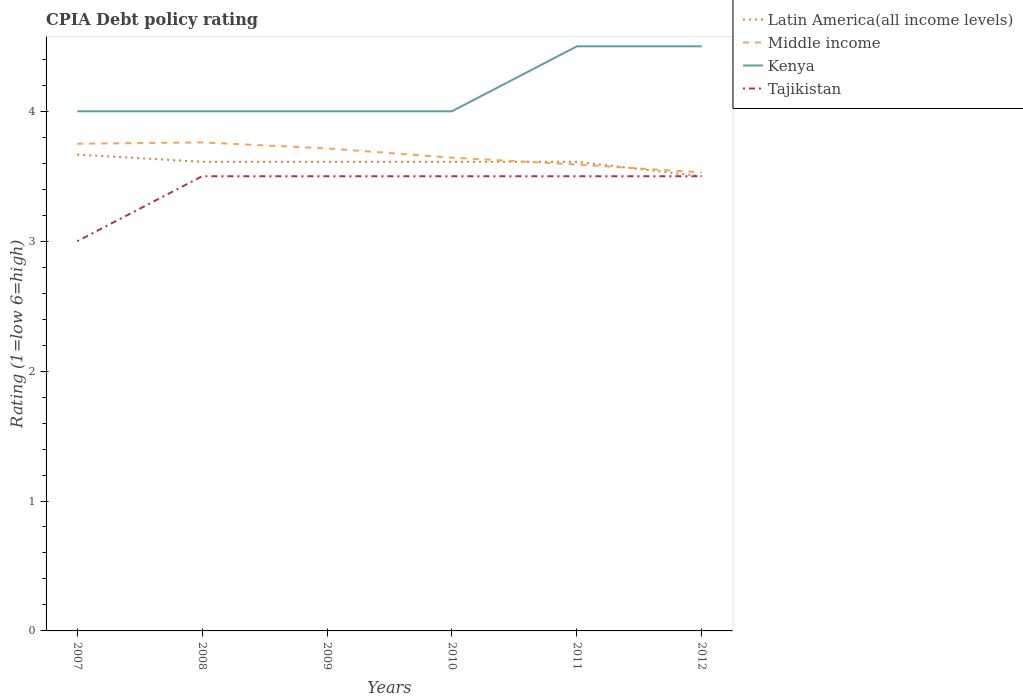Does the line corresponding to Latin America(all income levels) intersect with the line corresponding to Middle income?
Offer a very short reply. Yes. Is the number of lines equal to the number of legend labels?
Offer a terse response. Yes. Across all years, what is the maximum CPIA rating in Middle income?
Your answer should be very brief. 3.53. What is the total CPIA rating in Kenya in the graph?
Offer a very short reply. 0. What is the difference between the highest and the second highest CPIA rating in Latin America(all income levels)?
Your answer should be very brief. 0.17. What is the difference between the highest and the lowest CPIA rating in Kenya?
Your answer should be very brief. 2. Is the CPIA rating in Latin America(all income levels) strictly greater than the CPIA rating in Tajikistan over the years?
Your answer should be very brief. No. What is the difference between two consecutive major ticks on the Y-axis?
Ensure brevity in your answer.  1. Are the values on the major ticks of Y-axis written in scientific E-notation?
Give a very brief answer. No. What is the title of the graph?
Your response must be concise. CPIA Debt policy rating. What is the label or title of the Y-axis?
Ensure brevity in your answer.  Rating (1=low 6=high). What is the Rating (1=low 6=high) in Latin America(all income levels) in 2007?
Give a very brief answer. 3.67. What is the Rating (1=low 6=high) in Middle income in 2007?
Provide a short and direct response. 3.75. What is the Rating (1=low 6=high) of Tajikistan in 2007?
Ensure brevity in your answer.  3. What is the Rating (1=low 6=high) in Latin America(all income levels) in 2008?
Make the answer very short. 3.61. What is the Rating (1=low 6=high) of Middle income in 2008?
Offer a very short reply. 3.76. What is the Rating (1=low 6=high) of Kenya in 2008?
Offer a terse response. 4. What is the Rating (1=low 6=high) of Latin America(all income levels) in 2009?
Your response must be concise. 3.61. What is the Rating (1=low 6=high) of Middle income in 2009?
Give a very brief answer. 3.71. What is the Rating (1=low 6=high) of Tajikistan in 2009?
Keep it short and to the point. 3.5. What is the Rating (1=low 6=high) in Latin America(all income levels) in 2010?
Provide a short and direct response. 3.61. What is the Rating (1=low 6=high) of Middle income in 2010?
Offer a terse response. 3.64. What is the Rating (1=low 6=high) of Latin America(all income levels) in 2011?
Your answer should be very brief. 3.61. What is the Rating (1=low 6=high) in Middle income in 2011?
Your answer should be compact. 3.59. What is the Rating (1=low 6=high) of Tajikistan in 2011?
Offer a very short reply. 3.5. What is the Rating (1=low 6=high) in Latin America(all income levels) in 2012?
Offer a very short reply. 3.5. What is the Rating (1=low 6=high) in Middle income in 2012?
Offer a very short reply. 3.53. What is the Rating (1=low 6=high) in Kenya in 2012?
Offer a very short reply. 4.5. What is the Rating (1=low 6=high) of Tajikistan in 2012?
Provide a short and direct response. 3.5. Across all years, what is the maximum Rating (1=low 6=high) in Latin America(all income levels)?
Ensure brevity in your answer.  3.67. Across all years, what is the maximum Rating (1=low 6=high) of Middle income?
Ensure brevity in your answer.  3.76. Across all years, what is the minimum Rating (1=low 6=high) in Latin America(all income levels)?
Provide a short and direct response. 3.5. Across all years, what is the minimum Rating (1=low 6=high) of Middle income?
Make the answer very short. 3.53. What is the total Rating (1=low 6=high) in Latin America(all income levels) in the graph?
Your answer should be compact. 21.61. What is the total Rating (1=low 6=high) in Middle income in the graph?
Provide a succinct answer. 21.99. What is the total Rating (1=low 6=high) in Kenya in the graph?
Ensure brevity in your answer.  25. What is the difference between the Rating (1=low 6=high) in Latin America(all income levels) in 2007 and that in 2008?
Offer a very short reply. 0.06. What is the difference between the Rating (1=low 6=high) of Middle income in 2007 and that in 2008?
Your answer should be very brief. -0.01. What is the difference between the Rating (1=low 6=high) in Kenya in 2007 and that in 2008?
Give a very brief answer. 0. What is the difference between the Rating (1=low 6=high) in Tajikistan in 2007 and that in 2008?
Provide a short and direct response. -0.5. What is the difference between the Rating (1=low 6=high) in Latin America(all income levels) in 2007 and that in 2009?
Ensure brevity in your answer.  0.06. What is the difference between the Rating (1=low 6=high) of Middle income in 2007 and that in 2009?
Give a very brief answer. 0.04. What is the difference between the Rating (1=low 6=high) of Latin America(all income levels) in 2007 and that in 2010?
Offer a terse response. 0.06. What is the difference between the Rating (1=low 6=high) in Middle income in 2007 and that in 2010?
Ensure brevity in your answer.  0.11. What is the difference between the Rating (1=low 6=high) in Kenya in 2007 and that in 2010?
Your response must be concise. 0. What is the difference between the Rating (1=low 6=high) of Tajikistan in 2007 and that in 2010?
Offer a terse response. -0.5. What is the difference between the Rating (1=low 6=high) of Latin America(all income levels) in 2007 and that in 2011?
Provide a succinct answer. 0.06. What is the difference between the Rating (1=low 6=high) in Middle income in 2007 and that in 2011?
Your answer should be compact. 0.16. What is the difference between the Rating (1=low 6=high) in Kenya in 2007 and that in 2011?
Keep it short and to the point. -0.5. What is the difference between the Rating (1=low 6=high) of Middle income in 2007 and that in 2012?
Make the answer very short. 0.22. What is the difference between the Rating (1=low 6=high) in Kenya in 2007 and that in 2012?
Your answer should be compact. -0.5. What is the difference between the Rating (1=low 6=high) in Latin America(all income levels) in 2008 and that in 2009?
Offer a very short reply. 0. What is the difference between the Rating (1=low 6=high) of Middle income in 2008 and that in 2009?
Offer a very short reply. 0.05. What is the difference between the Rating (1=low 6=high) of Tajikistan in 2008 and that in 2009?
Provide a succinct answer. 0. What is the difference between the Rating (1=low 6=high) of Latin America(all income levels) in 2008 and that in 2010?
Offer a terse response. 0. What is the difference between the Rating (1=low 6=high) in Middle income in 2008 and that in 2010?
Your response must be concise. 0.12. What is the difference between the Rating (1=low 6=high) of Middle income in 2008 and that in 2011?
Ensure brevity in your answer.  0.17. What is the difference between the Rating (1=low 6=high) of Middle income in 2008 and that in 2012?
Your response must be concise. 0.23. What is the difference between the Rating (1=low 6=high) of Kenya in 2008 and that in 2012?
Provide a short and direct response. -0.5. What is the difference between the Rating (1=low 6=high) of Tajikistan in 2008 and that in 2012?
Provide a short and direct response. 0. What is the difference between the Rating (1=low 6=high) in Latin America(all income levels) in 2009 and that in 2010?
Offer a very short reply. 0. What is the difference between the Rating (1=low 6=high) in Middle income in 2009 and that in 2010?
Give a very brief answer. 0.07. What is the difference between the Rating (1=low 6=high) of Middle income in 2009 and that in 2011?
Provide a succinct answer. 0.12. What is the difference between the Rating (1=low 6=high) in Kenya in 2009 and that in 2011?
Your answer should be compact. -0.5. What is the difference between the Rating (1=low 6=high) in Latin America(all income levels) in 2009 and that in 2012?
Give a very brief answer. 0.11. What is the difference between the Rating (1=low 6=high) of Middle income in 2009 and that in 2012?
Offer a very short reply. 0.18. What is the difference between the Rating (1=low 6=high) of Kenya in 2009 and that in 2012?
Provide a succinct answer. -0.5. What is the difference between the Rating (1=low 6=high) in Tajikistan in 2009 and that in 2012?
Offer a very short reply. 0. What is the difference between the Rating (1=low 6=high) in Middle income in 2010 and that in 2011?
Your answer should be very brief. 0.05. What is the difference between the Rating (1=low 6=high) of Kenya in 2010 and that in 2011?
Keep it short and to the point. -0.5. What is the difference between the Rating (1=low 6=high) in Tajikistan in 2010 and that in 2011?
Make the answer very short. 0. What is the difference between the Rating (1=low 6=high) of Middle income in 2010 and that in 2012?
Your response must be concise. 0.11. What is the difference between the Rating (1=low 6=high) in Latin America(all income levels) in 2011 and that in 2012?
Keep it short and to the point. 0.11. What is the difference between the Rating (1=low 6=high) of Middle income in 2011 and that in 2012?
Ensure brevity in your answer.  0.06. What is the difference between the Rating (1=low 6=high) of Latin America(all income levels) in 2007 and the Rating (1=low 6=high) of Middle income in 2008?
Your answer should be compact. -0.09. What is the difference between the Rating (1=low 6=high) in Middle income in 2007 and the Rating (1=low 6=high) in Kenya in 2008?
Provide a succinct answer. -0.25. What is the difference between the Rating (1=low 6=high) of Latin America(all income levels) in 2007 and the Rating (1=low 6=high) of Middle income in 2009?
Keep it short and to the point. -0.05. What is the difference between the Rating (1=low 6=high) in Latin America(all income levels) in 2007 and the Rating (1=low 6=high) in Kenya in 2009?
Provide a short and direct response. -0.33. What is the difference between the Rating (1=low 6=high) of Latin America(all income levels) in 2007 and the Rating (1=low 6=high) of Tajikistan in 2009?
Provide a short and direct response. 0.17. What is the difference between the Rating (1=low 6=high) of Middle income in 2007 and the Rating (1=low 6=high) of Tajikistan in 2009?
Ensure brevity in your answer.  0.25. What is the difference between the Rating (1=low 6=high) of Kenya in 2007 and the Rating (1=low 6=high) of Tajikistan in 2009?
Provide a succinct answer. 0.5. What is the difference between the Rating (1=low 6=high) in Latin America(all income levels) in 2007 and the Rating (1=low 6=high) in Middle income in 2010?
Offer a terse response. 0.02. What is the difference between the Rating (1=low 6=high) of Latin America(all income levels) in 2007 and the Rating (1=low 6=high) of Kenya in 2010?
Offer a terse response. -0.33. What is the difference between the Rating (1=low 6=high) of Latin America(all income levels) in 2007 and the Rating (1=low 6=high) of Tajikistan in 2010?
Offer a terse response. 0.17. What is the difference between the Rating (1=low 6=high) of Latin America(all income levels) in 2007 and the Rating (1=low 6=high) of Middle income in 2011?
Your answer should be compact. 0.08. What is the difference between the Rating (1=low 6=high) of Latin America(all income levels) in 2007 and the Rating (1=low 6=high) of Kenya in 2011?
Ensure brevity in your answer.  -0.83. What is the difference between the Rating (1=low 6=high) of Latin America(all income levels) in 2007 and the Rating (1=low 6=high) of Tajikistan in 2011?
Ensure brevity in your answer.  0.17. What is the difference between the Rating (1=low 6=high) of Middle income in 2007 and the Rating (1=low 6=high) of Kenya in 2011?
Your response must be concise. -0.75. What is the difference between the Rating (1=low 6=high) in Latin America(all income levels) in 2007 and the Rating (1=low 6=high) in Middle income in 2012?
Your response must be concise. 0.14. What is the difference between the Rating (1=low 6=high) in Middle income in 2007 and the Rating (1=low 6=high) in Kenya in 2012?
Provide a short and direct response. -0.75. What is the difference between the Rating (1=low 6=high) of Middle income in 2007 and the Rating (1=low 6=high) of Tajikistan in 2012?
Your response must be concise. 0.25. What is the difference between the Rating (1=low 6=high) of Kenya in 2007 and the Rating (1=low 6=high) of Tajikistan in 2012?
Make the answer very short. 0.5. What is the difference between the Rating (1=low 6=high) in Latin America(all income levels) in 2008 and the Rating (1=low 6=high) in Middle income in 2009?
Provide a succinct answer. -0.1. What is the difference between the Rating (1=low 6=high) in Latin America(all income levels) in 2008 and the Rating (1=low 6=high) in Kenya in 2009?
Give a very brief answer. -0.39. What is the difference between the Rating (1=low 6=high) in Latin America(all income levels) in 2008 and the Rating (1=low 6=high) in Tajikistan in 2009?
Ensure brevity in your answer.  0.11. What is the difference between the Rating (1=low 6=high) in Middle income in 2008 and the Rating (1=low 6=high) in Kenya in 2009?
Provide a succinct answer. -0.24. What is the difference between the Rating (1=low 6=high) in Middle income in 2008 and the Rating (1=low 6=high) in Tajikistan in 2009?
Give a very brief answer. 0.26. What is the difference between the Rating (1=low 6=high) of Latin America(all income levels) in 2008 and the Rating (1=low 6=high) of Middle income in 2010?
Make the answer very short. -0.03. What is the difference between the Rating (1=low 6=high) in Latin America(all income levels) in 2008 and the Rating (1=low 6=high) in Kenya in 2010?
Make the answer very short. -0.39. What is the difference between the Rating (1=low 6=high) of Middle income in 2008 and the Rating (1=low 6=high) of Kenya in 2010?
Provide a succinct answer. -0.24. What is the difference between the Rating (1=low 6=high) of Middle income in 2008 and the Rating (1=low 6=high) of Tajikistan in 2010?
Offer a terse response. 0.26. What is the difference between the Rating (1=low 6=high) in Kenya in 2008 and the Rating (1=low 6=high) in Tajikistan in 2010?
Give a very brief answer. 0.5. What is the difference between the Rating (1=low 6=high) of Latin America(all income levels) in 2008 and the Rating (1=low 6=high) of Middle income in 2011?
Offer a terse response. 0.02. What is the difference between the Rating (1=low 6=high) in Latin America(all income levels) in 2008 and the Rating (1=low 6=high) in Kenya in 2011?
Provide a succinct answer. -0.89. What is the difference between the Rating (1=low 6=high) in Middle income in 2008 and the Rating (1=low 6=high) in Kenya in 2011?
Provide a succinct answer. -0.74. What is the difference between the Rating (1=low 6=high) of Middle income in 2008 and the Rating (1=low 6=high) of Tajikistan in 2011?
Offer a very short reply. 0.26. What is the difference between the Rating (1=low 6=high) of Kenya in 2008 and the Rating (1=low 6=high) of Tajikistan in 2011?
Offer a terse response. 0.5. What is the difference between the Rating (1=low 6=high) in Latin America(all income levels) in 2008 and the Rating (1=low 6=high) in Middle income in 2012?
Your answer should be compact. 0.08. What is the difference between the Rating (1=low 6=high) of Latin America(all income levels) in 2008 and the Rating (1=low 6=high) of Kenya in 2012?
Your response must be concise. -0.89. What is the difference between the Rating (1=low 6=high) of Latin America(all income levels) in 2008 and the Rating (1=low 6=high) of Tajikistan in 2012?
Make the answer very short. 0.11. What is the difference between the Rating (1=low 6=high) in Middle income in 2008 and the Rating (1=low 6=high) in Kenya in 2012?
Offer a terse response. -0.74. What is the difference between the Rating (1=low 6=high) of Middle income in 2008 and the Rating (1=low 6=high) of Tajikistan in 2012?
Give a very brief answer. 0.26. What is the difference between the Rating (1=low 6=high) in Latin America(all income levels) in 2009 and the Rating (1=low 6=high) in Middle income in 2010?
Ensure brevity in your answer.  -0.03. What is the difference between the Rating (1=low 6=high) of Latin America(all income levels) in 2009 and the Rating (1=low 6=high) of Kenya in 2010?
Your answer should be compact. -0.39. What is the difference between the Rating (1=low 6=high) of Middle income in 2009 and the Rating (1=low 6=high) of Kenya in 2010?
Your response must be concise. -0.29. What is the difference between the Rating (1=low 6=high) of Middle income in 2009 and the Rating (1=low 6=high) of Tajikistan in 2010?
Ensure brevity in your answer.  0.21. What is the difference between the Rating (1=low 6=high) in Kenya in 2009 and the Rating (1=low 6=high) in Tajikistan in 2010?
Provide a short and direct response. 0.5. What is the difference between the Rating (1=low 6=high) in Latin America(all income levels) in 2009 and the Rating (1=low 6=high) in Middle income in 2011?
Make the answer very short. 0.02. What is the difference between the Rating (1=low 6=high) in Latin America(all income levels) in 2009 and the Rating (1=low 6=high) in Kenya in 2011?
Your response must be concise. -0.89. What is the difference between the Rating (1=low 6=high) of Middle income in 2009 and the Rating (1=low 6=high) of Kenya in 2011?
Your answer should be very brief. -0.79. What is the difference between the Rating (1=low 6=high) of Middle income in 2009 and the Rating (1=low 6=high) of Tajikistan in 2011?
Offer a very short reply. 0.21. What is the difference between the Rating (1=low 6=high) of Latin America(all income levels) in 2009 and the Rating (1=low 6=high) of Middle income in 2012?
Your answer should be compact. 0.08. What is the difference between the Rating (1=low 6=high) in Latin America(all income levels) in 2009 and the Rating (1=low 6=high) in Kenya in 2012?
Your answer should be very brief. -0.89. What is the difference between the Rating (1=low 6=high) of Latin America(all income levels) in 2009 and the Rating (1=low 6=high) of Tajikistan in 2012?
Provide a succinct answer. 0.11. What is the difference between the Rating (1=low 6=high) in Middle income in 2009 and the Rating (1=low 6=high) in Kenya in 2012?
Offer a terse response. -0.79. What is the difference between the Rating (1=low 6=high) of Middle income in 2009 and the Rating (1=low 6=high) of Tajikistan in 2012?
Keep it short and to the point. 0.21. What is the difference between the Rating (1=low 6=high) of Latin America(all income levels) in 2010 and the Rating (1=low 6=high) of Middle income in 2011?
Provide a succinct answer. 0.02. What is the difference between the Rating (1=low 6=high) of Latin America(all income levels) in 2010 and the Rating (1=low 6=high) of Kenya in 2011?
Give a very brief answer. -0.89. What is the difference between the Rating (1=low 6=high) in Latin America(all income levels) in 2010 and the Rating (1=low 6=high) in Tajikistan in 2011?
Ensure brevity in your answer.  0.11. What is the difference between the Rating (1=low 6=high) in Middle income in 2010 and the Rating (1=low 6=high) in Kenya in 2011?
Offer a terse response. -0.86. What is the difference between the Rating (1=low 6=high) in Middle income in 2010 and the Rating (1=low 6=high) in Tajikistan in 2011?
Give a very brief answer. 0.14. What is the difference between the Rating (1=low 6=high) of Kenya in 2010 and the Rating (1=low 6=high) of Tajikistan in 2011?
Your answer should be very brief. 0.5. What is the difference between the Rating (1=low 6=high) of Latin America(all income levels) in 2010 and the Rating (1=low 6=high) of Middle income in 2012?
Provide a short and direct response. 0.08. What is the difference between the Rating (1=low 6=high) of Latin America(all income levels) in 2010 and the Rating (1=low 6=high) of Kenya in 2012?
Keep it short and to the point. -0.89. What is the difference between the Rating (1=low 6=high) of Latin America(all income levels) in 2010 and the Rating (1=low 6=high) of Tajikistan in 2012?
Keep it short and to the point. 0.11. What is the difference between the Rating (1=low 6=high) of Middle income in 2010 and the Rating (1=low 6=high) of Kenya in 2012?
Your response must be concise. -0.86. What is the difference between the Rating (1=low 6=high) in Middle income in 2010 and the Rating (1=low 6=high) in Tajikistan in 2012?
Offer a very short reply. 0.14. What is the difference between the Rating (1=low 6=high) in Latin America(all income levels) in 2011 and the Rating (1=low 6=high) in Middle income in 2012?
Give a very brief answer. 0.08. What is the difference between the Rating (1=low 6=high) of Latin America(all income levels) in 2011 and the Rating (1=low 6=high) of Kenya in 2012?
Provide a short and direct response. -0.89. What is the difference between the Rating (1=low 6=high) in Middle income in 2011 and the Rating (1=low 6=high) in Kenya in 2012?
Give a very brief answer. -0.91. What is the difference between the Rating (1=low 6=high) of Middle income in 2011 and the Rating (1=low 6=high) of Tajikistan in 2012?
Your response must be concise. 0.09. What is the average Rating (1=low 6=high) of Latin America(all income levels) per year?
Ensure brevity in your answer.  3.6. What is the average Rating (1=low 6=high) of Middle income per year?
Keep it short and to the point. 3.66. What is the average Rating (1=low 6=high) in Kenya per year?
Your answer should be compact. 4.17. What is the average Rating (1=low 6=high) in Tajikistan per year?
Your answer should be very brief. 3.42. In the year 2007, what is the difference between the Rating (1=low 6=high) in Latin America(all income levels) and Rating (1=low 6=high) in Middle income?
Offer a terse response. -0.08. In the year 2007, what is the difference between the Rating (1=low 6=high) of Latin America(all income levels) and Rating (1=low 6=high) of Kenya?
Offer a very short reply. -0.33. In the year 2007, what is the difference between the Rating (1=low 6=high) of Kenya and Rating (1=low 6=high) of Tajikistan?
Offer a terse response. 1. In the year 2008, what is the difference between the Rating (1=low 6=high) in Latin America(all income levels) and Rating (1=low 6=high) in Middle income?
Offer a very short reply. -0.15. In the year 2008, what is the difference between the Rating (1=low 6=high) in Latin America(all income levels) and Rating (1=low 6=high) in Kenya?
Provide a succinct answer. -0.39. In the year 2008, what is the difference between the Rating (1=low 6=high) of Latin America(all income levels) and Rating (1=low 6=high) of Tajikistan?
Provide a short and direct response. 0.11. In the year 2008, what is the difference between the Rating (1=low 6=high) in Middle income and Rating (1=low 6=high) in Kenya?
Provide a short and direct response. -0.24. In the year 2008, what is the difference between the Rating (1=low 6=high) of Middle income and Rating (1=low 6=high) of Tajikistan?
Give a very brief answer. 0.26. In the year 2008, what is the difference between the Rating (1=low 6=high) of Kenya and Rating (1=low 6=high) of Tajikistan?
Your answer should be compact. 0.5. In the year 2009, what is the difference between the Rating (1=low 6=high) of Latin America(all income levels) and Rating (1=low 6=high) of Middle income?
Your response must be concise. -0.1. In the year 2009, what is the difference between the Rating (1=low 6=high) of Latin America(all income levels) and Rating (1=low 6=high) of Kenya?
Your response must be concise. -0.39. In the year 2009, what is the difference between the Rating (1=low 6=high) in Middle income and Rating (1=low 6=high) in Kenya?
Offer a very short reply. -0.29. In the year 2009, what is the difference between the Rating (1=low 6=high) of Middle income and Rating (1=low 6=high) of Tajikistan?
Provide a succinct answer. 0.21. In the year 2009, what is the difference between the Rating (1=low 6=high) of Kenya and Rating (1=low 6=high) of Tajikistan?
Give a very brief answer. 0.5. In the year 2010, what is the difference between the Rating (1=low 6=high) in Latin America(all income levels) and Rating (1=low 6=high) in Middle income?
Ensure brevity in your answer.  -0.03. In the year 2010, what is the difference between the Rating (1=low 6=high) in Latin America(all income levels) and Rating (1=low 6=high) in Kenya?
Provide a short and direct response. -0.39. In the year 2010, what is the difference between the Rating (1=low 6=high) of Latin America(all income levels) and Rating (1=low 6=high) of Tajikistan?
Give a very brief answer. 0.11. In the year 2010, what is the difference between the Rating (1=low 6=high) in Middle income and Rating (1=low 6=high) in Kenya?
Your answer should be very brief. -0.36. In the year 2010, what is the difference between the Rating (1=low 6=high) of Middle income and Rating (1=low 6=high) of Tajikistan?
Keep it short and to the point. 0.14. In the year 2010, what is the difference between the Rating (1=low 6=high) of Kenya and Rating (1=low 6=high) of Tajikistan?
Offer a terse response. 0.5. In the year 2011, what is the difference between the Rating (1=low 6=high) in Latin America(all income levels) and Rating (1=low 6=high) in Middle income?
Offer a terse response. 0.02. In the year 2011, what is the difference between the Rating (1=low 6=high) of Latin America(all income levels) and Rating (1=low 6=high) of Kenya?
Provide a succinct answer. -0.89. In the year 2011, what is the difference between the Rating (1=low 6=high) of Middle income and Rating (1=low 6=high) of Kenya?
Give a very brief answer. -0.91. In the year 2011, what is the difference between the Rating (1=low 6=high) of Middle income and Rating (1=low 6=high) of Tajikistan?
Your answer should be very brief. 0.09. In the year 2011, what is the difference between the Rating (1=low 6=high) of Kenya and Rating (1=low 6=high) of Tajikistan?
Your answer should be compact. 1. In the year 2012, what is the difference between the Rating (1=low 6=high) in Latin America(all income levels) and Rating (1=low 6=high) in Middle income?
Your response must be concise. -0.03. In the year 2012, what is the difference between the Rating (1=low 6=high) in Latin America(all income levels) and Rating (1=low 6=high) in Kenya?
Keep it short and to the point. -1. In the year 2012, what is the difference between the Rating (1=low 6=high) in Latin America(all income levels) and Rating (1=low 6=high) in Tajikistan?
Offer a terse response. 0. In the year 2012, what is the difference between the Rating (1=low 6=high) of Middle income and Rating (1=low 6=high) of Kenya?
Offer a terse response. -0.97. In the year 2012, what is the difference between the Rating (1=low 6=high) of Middle income and Rating (1=low 6=high) of Tajikistan?
Your answer should be compact. 0.03. What is the ratio of the Rating (1=low 6=high) in Latin America(all income levels) in 2007 to that in 2008?
Make the answer very short. 1.02. What is the ratio of the Rating (1=low 6=high) in Tajikistan in 2007 to that in 2008?
Offer a terse response. 0.86. What is the ratio of the Rating (1=low 6=high) in Latin America(all income levels) in 2007 to that in 2009?
Ensure brevity in your answer.  1.02. What is the ratio of the Rating (1=low 6=high) of Middle income in 2007 to that in 2009?
Give a very brief answer. 1.01. What is the ratio of the Rating (1=low 6=high) in Kenya in 2007 to that in 2009?
Offer a very short reply. 1. What is the ratio of the Rating (1=low 6=high) in Latin America(all income levels) in 2007 to that in 2010?
Your response must be concise. 1.02. What is the ratio of the Rating (1=low 6=high) in Middle income in 2007 to that in 2010?
Your response must be concise. 1.03. What is the ratio of the Rating (1=low 6=high) in Kenya in 2007 to that in 2010?
Ensure brevity in your answer.  1. What is the ratio of the Rating (1=low 6=high) of Tajikistan in 2007 to that in 2010?
Keep it short and to the point. 0.86. What is the ratio of the Rating (1=low 6=high) of Latin America(all income levels) in 2007 to that in 2011?
Keep it short and to the point. 1.02. What is the ratio of the Rating (1=low 6=high) in Middle income in 2007 to that in 2011?
Your answer should be compact. 1.04. What is the ratio of the Rating (1=low 6=high) in Tajikistan in 2007 to that in 2011?
Offer a very short reply. 0.86. What is the ratio of the Rating (1=low 6=high) of Latin America(all income levels) in 2007 to that in 2012?
Give a very brief answer. 1.05. What is the ratio of the Rating (1=low 6=high) in Middle income in 2007 to that in 2012?
Your answer should be very brief. 1.06. What is the ratio of the Rating (1=low 6=high) in Kenya in 2007 to that in 2012?
Your answer should be compact. 0.89. What is the ratio of the Rating (1=low 6=high) of Tajikistan in 2007 to that in 2012?
Provide a succinct answer. 0.86. What is the ratio of the Rating (1=low 6=high) in Middle income in 2008 to that in 2009?
Your response must be concise. 1.01. What is the ratio of the Rating (1=low 6=high) in Middle income in 2008 to that in 2010?
Keep it short and to the point. 1.03. What is the ratio of the Rating (1=low 6=high) of Tajikistan in 2008 to that in 2010?
Your answer should be compact. 1. What is the ratio of the Rating (1=low 6=high) in Latin America(all income levels) in 2008 to that in 2011?
Give a very brief answer. 1. What is the ratio of the Rating (1=low 6=high) in Middle income in 2008 to that in 2011?
Your answer should be compact. 1.05. What is the ratio of the Rating (1=low 6=high) in Latin America(all income levels) in 2008 to that in 2012?
Keep it short and to the point. 1.03. What is the ratio of the Rating (1=low 6=high) in Middle income in 2008 to that in 2012?
Offer a very short reply. 1.07. What is the ratio of the Rating (1=low 6=high) in Kenya in 2008 to that in 2012?
Provide a succinct answer. 0.89. What is the ratio of the Rating (1=low 6=high) in Tajikistan in 2008 to that in 2012?
Give a very brief answer. 1. What is the ratio of the Rating (1=low 6=high) of Middle income in 2009 to that in 2010?
Keep it short and to the point. 1.02. What is the ratio of the Rating (1=low 6=high) of Latin America(all income levels) in 2009 to that in 2011?
Make the answer very short. 1. What is the ratio of the Rating (1=low 6=high) in Middle income in 2009 to that in 2011?
Your answer should be very brief. 1.03. What is the ratio of the Rating (1=low 6=high) of Kenya in 2009 to that in 2011?
Keep it short and to the point. 0.89. What is the ratio of the Rating (1=low 6=high) of Tajikistan in 2009 to that in 2011?
Offer a terse response. 1. What is the ratio of the Rating (1=low 6=high) of Latin America(all income levels) in 2009 to that in 2012?
Offer a very short reply. 1.03. What is the ratio of the Rating (1=low 6=high) in Middle income in 2009 to that in 2012?
Your response must be concise. 1.05. What is the ratio of the Rating (1=low 6=high) of Kenya in 2009 to that in 2012?
Make the answer very short. 0.89. What is the ratio of the Rating (1=low 6=high) of Tajikistan in 2009 to that in 2012?
Your answer should be compact. 1. What is the ratio of the Rating (1=low 6=high) in Latin America(all income levels) in 2010 to that in 2011?
Make the answer very short. 1. What is the ratio of the Rating (1=low 6=high) in Middle income in 2010 to that in 2011?
Provide a succinct answer. 1.01. What is the ratio of the Rating (1=low 6=high) of Kenya in 2010 to that in 2011?
Make the answer very short. 0.89. What is the ratio of the Rating (1=low 6=high) of Latin America(all income levels) in 2010 to that in 2012?
Give a very brief answer. 1.03. What is the ratio of the Rating (1=low 6=high) in Middle income in 2010 to that in 2012?
Offer a terse response. 1.03. What is the ratio of the Rating (1=low 6=high) of Kenya in 2010 to that in 2012?
Ensure brevity in your answer.  0.89. What is the ratio of the Rating (1=low 6=high) of Tajikistan in 2010 to that in 2012?
Your response must be concise. 1. What is the ratio of the Rating (1=low 6=high) of Latin America(all income levels) in 2011 to that in 2012?
Your answer should be compact. 1.03. What is the ratio of the Rating (1=low 6=high) in Middle income in 2011 to that in 2012?
Make the answer very short. 1.02. What is the ratio of the Rating (1=low 6=high) of Kenya in 2011 to that in 2012?
Your answer should be very brief. 1. What is the ratio of the Rating (1=low 6=high) of Tajikistan in 2011 to that in 2012?
Offer a very short reply. 1. What is the difference between the highest and the second highest Rating (1=low 6=high) in Latin America(all income levels)?
Provide a succinct answer. 0.06. What is the difference between the highest and the second highest Rating (1=low 6=high) in Middle income?
Ensure brevity in your answer.  0.01. What is the difference between the highest and the second highest Rating (1=low 6=high) of Kenya?
Provide a succinct answer. 0. What is the difference between the highest and the second highest Rating (1=low 6=high) of Tajikistan?
Keep it short and to the point. 0. What is the difference between the highest and the lowest Rating (1=low 6=high) in Middle income?
Provide a succinct answer. 0.23. What is the difference between the highest and the lowest Rating (1=low 6=high) in Kenya?
Your response must be concise. 0.5. What is the difference between the highest and the lowest Rating (1=low 6=high) in Tajikistan?
Make the answer very short. 0.5. 